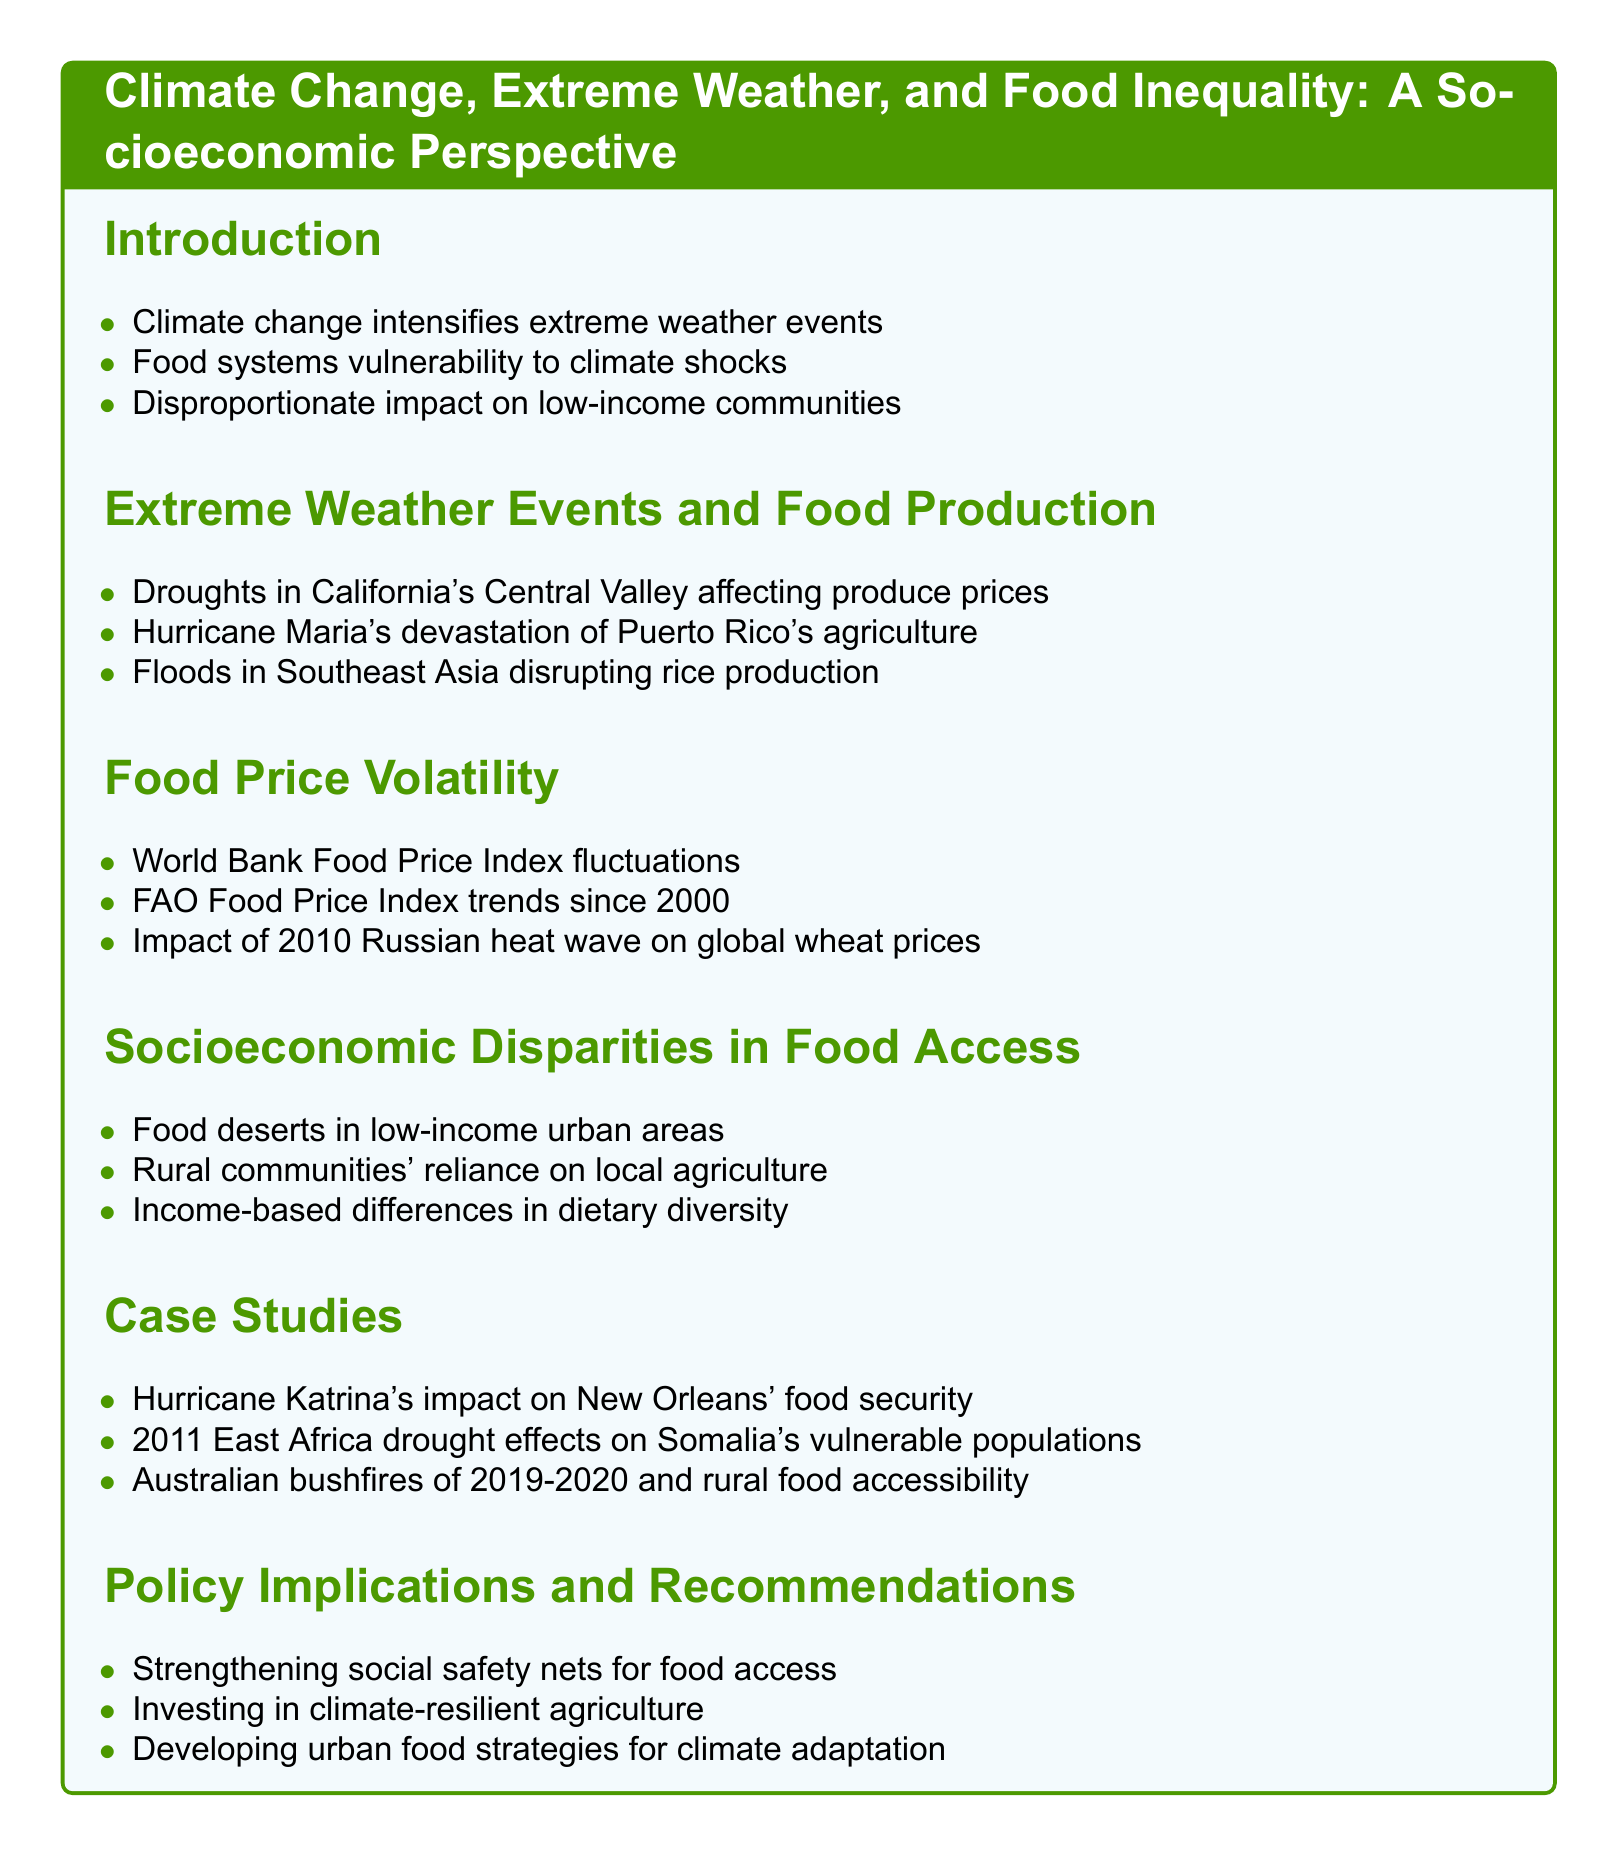What is the title of the document? The title is clearly stated at the beginning of the document.
Answer: Climate Change, Extreme Weather, and Food Inequality: A Socioeconomic Perspective Which region is affected by droughts mentioned in the document? The document highlights specific regions impacted by extreme weather events.
Answer: California's Central Valley What extreme weather event devastated Puerto Rico's agriculture? The document lists specific events that impacted food production.
Answer: Hurricane Maria What trend has the FAO Food Price Index shown since 2000? The document discusses trends in food price volatility over time.
Answer: Trends What is one example of socioeconomic disparity in food access? The document outlines various disparities in food accessibility by socioeconomic status.
Answer: Food deserts in low-income urban areas How many case studies are mentioned in the document? The document includes a specific number of case studies as examples.
Answer: Three What policy suggests strengthening social safety nets? The document provides recommendations for addressing food access issues.
Answer: Strengthening social safety nets for food access Which event affected global wheat prices in 2010? The document references specific events that caused food price volatility.
Answer: Russian heat wave What disaster impacted New Orleans' food security? The document highlights case studies of past disasters affecting food security.
Answer: Hurricane Katrina 